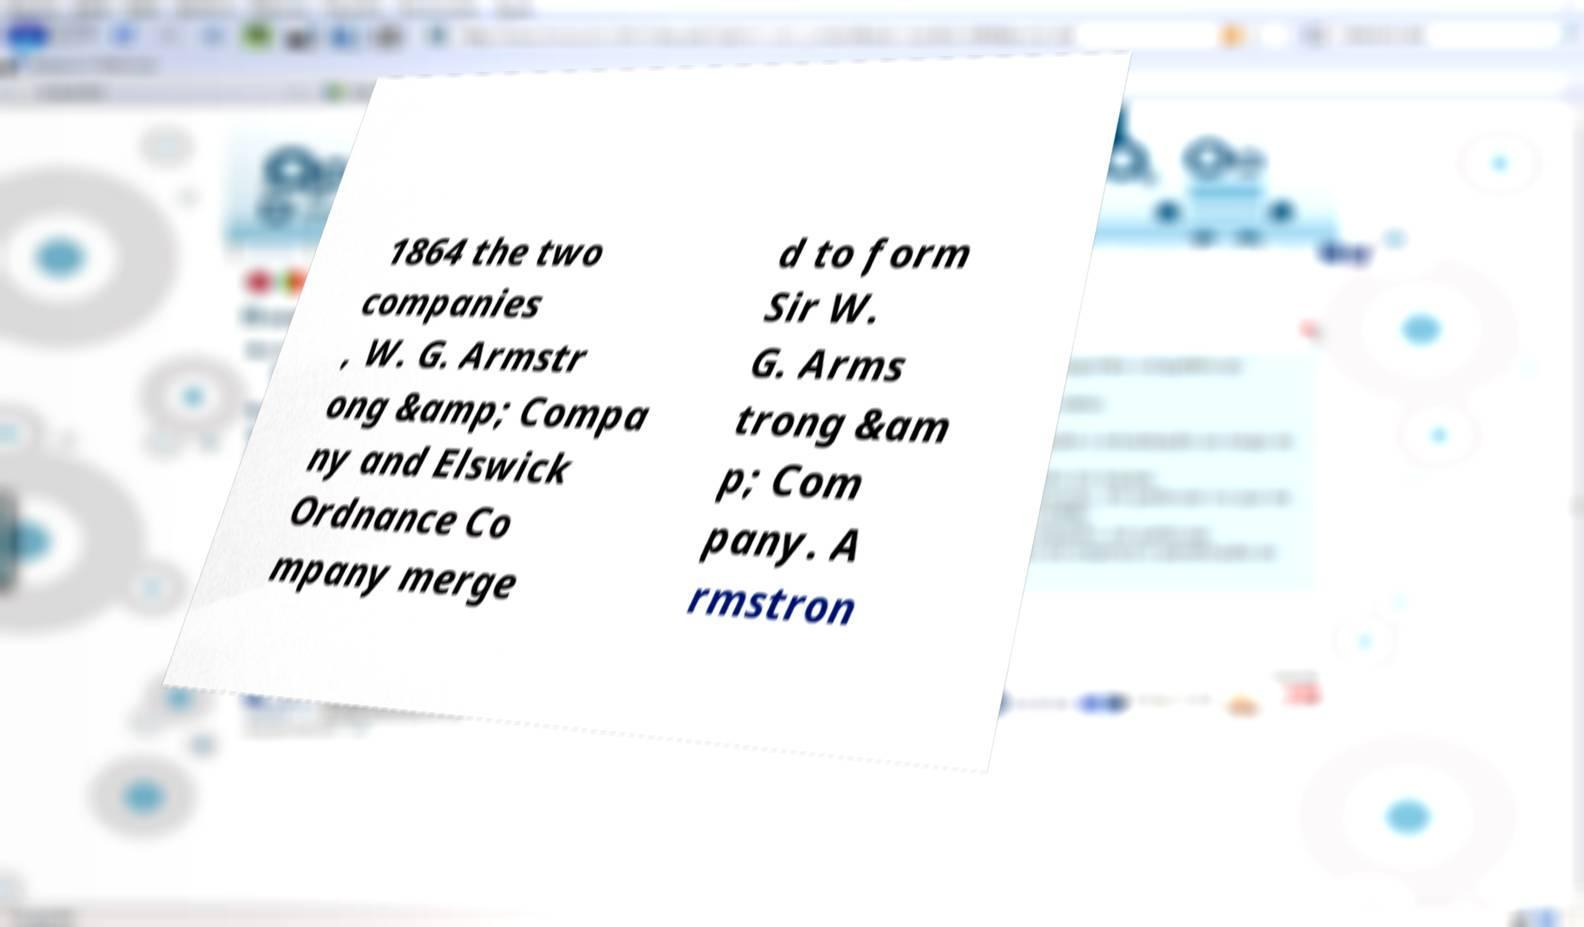For documentation purposes, I need the text within this image transcribed. Could you provide that? 1864 the two companies , W. G. Armstr ong &amp; Compa ny and Elswick Ordnance Co mpany merge d to form Sir W. G. Arms trong &am p; Com pany. A rmstron 